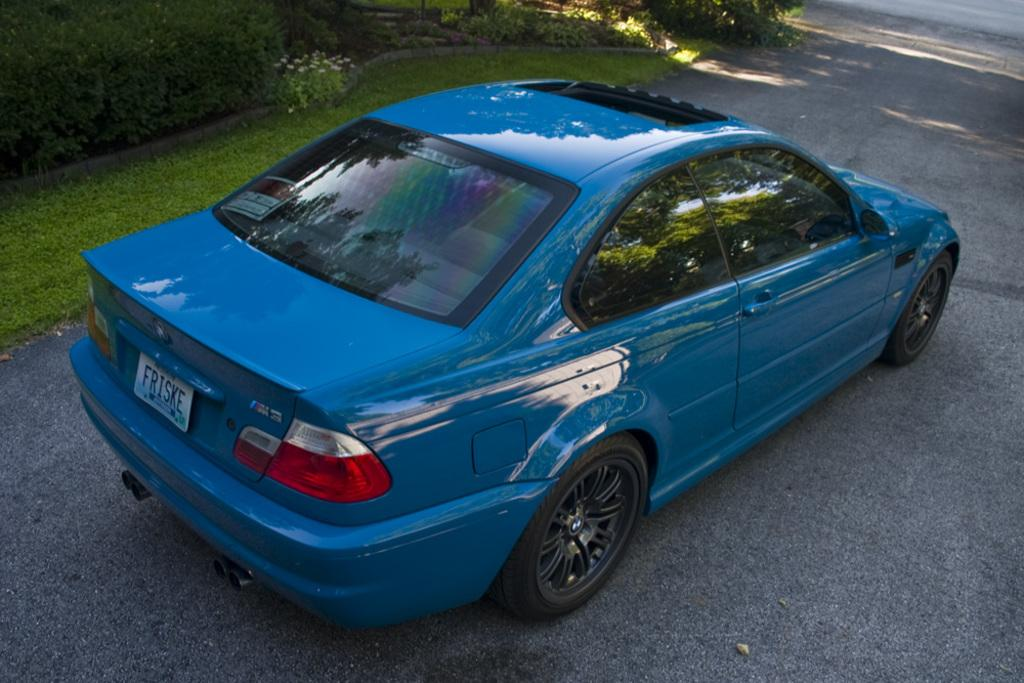What is the main feature of the image? There is a road in the image. What type of vehicle is on the road? There is a blue and black car on the road. What natural elements can be seen in the image? There are green trees, grass, and white flowers visible in the image. What type of dinner is being served in the image? There is no dinner or any indication of food in the image; it primarily features a road, a car, trees, grass, and flowers. 